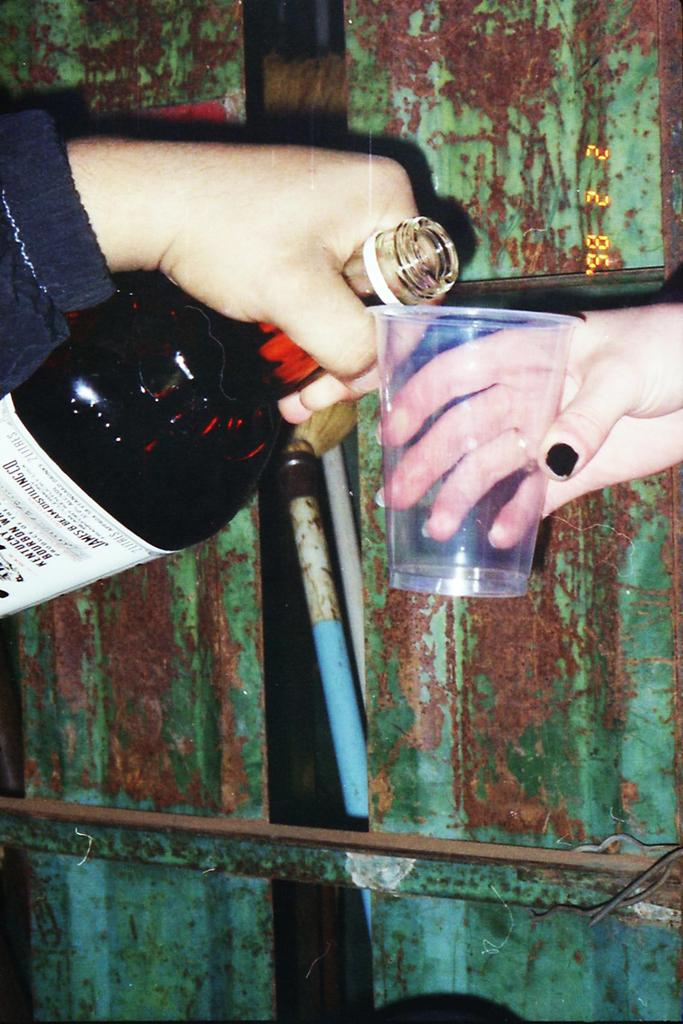What is being held by the hand on the right side of the image? There is a glass being held by the hand on the right side of the image. What is the person on the left side of the image holding? The person on the left side of the image is holding a bottle. What type of objects can be seen in the background of the image? There are iron objects in the background of the image. What color is the sock on the person's foot in the image? There is no sock visible in the image; only a hand holding a glass and a person holding a bottle are present. 